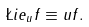<formula> <loc_0><loc_0><loc_500><loc_500>\L i e _ { u } f \equiv u f .</formula> 